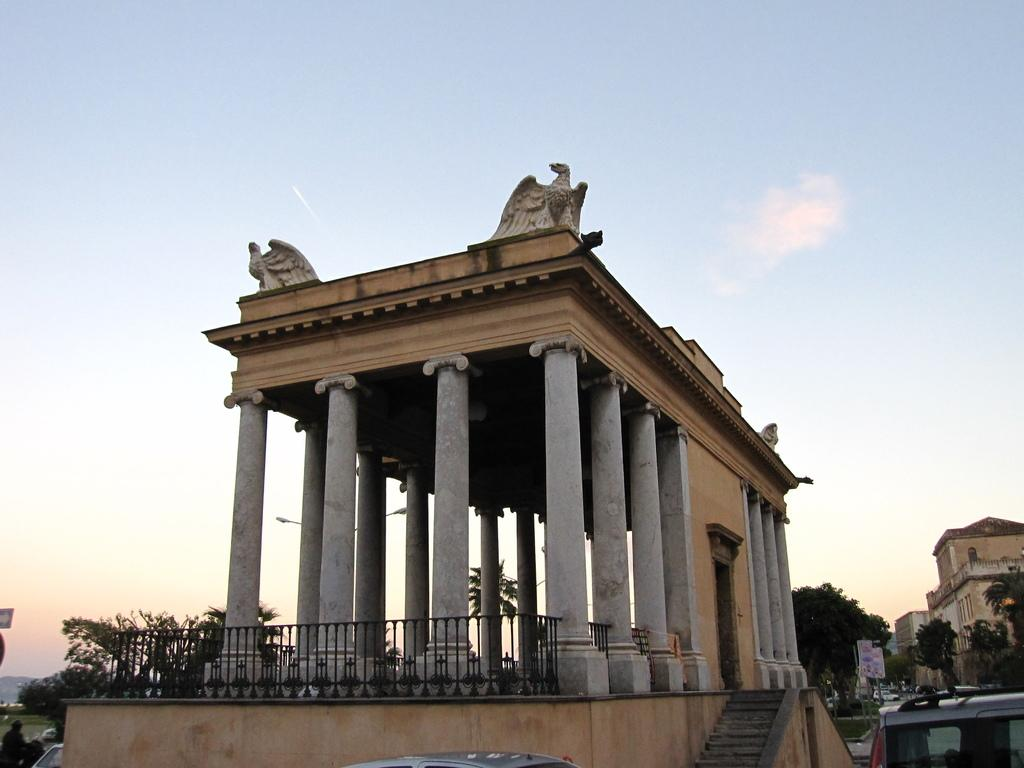What type of structures can be seen in the image? There are buildings in the image. What other natural elements are present in the image? There are trees in the image. What man-made objects can be seen in the image? There are vehicles, boards, and railing in the image. Are there any architectural features that allow for movement between different levels? Yes, there are stairs in the image. What is visible in the background of the image? The sky is visible in the background of the image. What note is attached to the railing in the image? There is no note attached to the railing in the image. What is the wish of the person standing next to the tree in the image? There is no person standing next to the tree in the image, and therefore no wish can be attributed to them. 